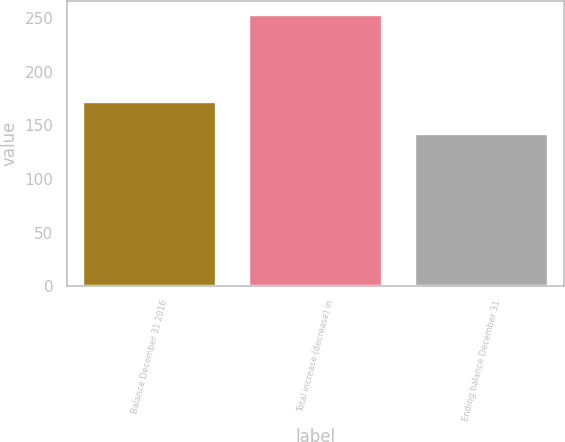Convert chart to OTSL. <chart><loc_0><loc_0><loc_500><loc_500><bar_chart><fcel>Balance December 31 2016<fcel>Total increase (decrease) in<fcel>Ending balance December 31<nl><fcel>172<fcel>253<fcel>142<nl></chart> 